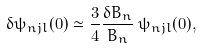<formula> <loc_0><loc_0><loc_500><loc_500>\delta \psi _ { n j l } ( 0 ) \simeq \frac { 3 } { 4 } \frac { \delta B _ { n } } { B _ { n } } \, \psi _ { n j l } ( 0 ) ,</formula> 